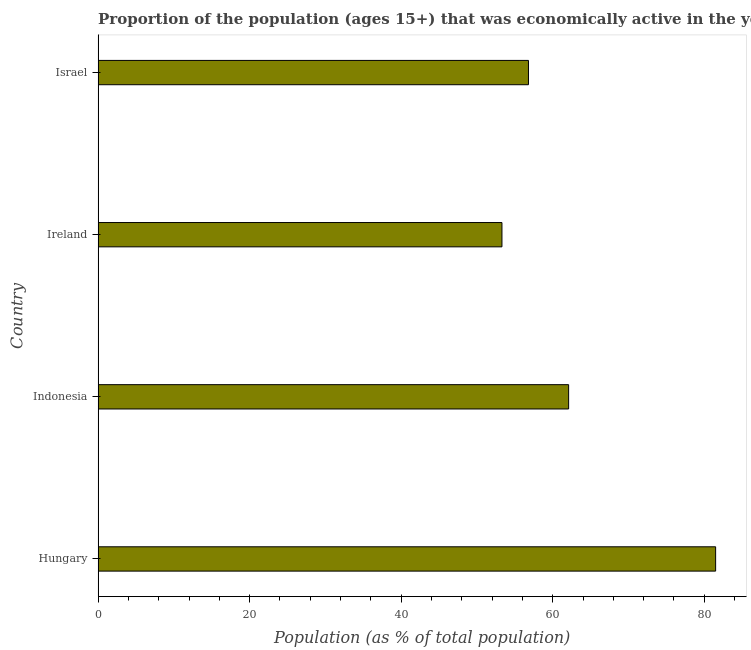Does the graph contain any zero values?
Offer a terse response. No. Does the graph contain grids?
Make the answer very short. No. What is the title of the graph?
Provide a short and direct response. Proportion of the population (ages 15+) that was economically active in the year 1985. What is the label or title of the X-axis?
Keep it short and to the point. Population (as % of total population). What is the percentage of economically active population in Indonesia?
Your answer should be very brief. 62.1. Across all countries, what is the maximum percentage of economically active population?
Make the answer very short. 81.5. Across all countries, what is the minimum percentage of economically active population?
Your answer should be compact. 53.3. In which country was the percentage of economically active population maximum?
Offer a terse response. Hungary. In which country was the percentage of economically active population minimum?
Offer a terse response. Ireland. What is the sum of the percentage of economically active population?
Ensure brevity in your answer.  253.7. What is the difference between the percentage of economically active population in Indonesia and Ireland?
Your response must be concise. 8.8. What is the average percentage of economically active population per country?
Offer a terse response. 63.42. What is the median percentage of economically active population?
Offer a very short reply. 59.45. In how many countries, is the percentage of economically active population greater than 72 %?
Your response must be concise. 1. What is the ratio of the percentage of economically active population in Hungary to that in Indonesia?
Provide a short and direct response. 1.31. Is the difference between the percentage of economically active population in Ireland and Israel greater than the difference between any two countries?
Offer a terse response. No. What is the difference between the highest and the second highest percentage of economically active population?
Your answer should be very brief. 19.4. What is the difference between the highest and the lowest percentage of economically active population?
Your answer should be compact. 28.2. In how many countries, is the percentage of economically active population greater than the average percentage of economically active population taken over all countries?
Ensure brevity in your answer.  1. How many bars are there?
Provide a short and direct response. 4. Are all the bars in the graph horizontal?
Your response must be concise. Yes. What is the difference between two consecutive major ticks on the X-axis?
Offer a terse response. 20. What is the Population (as % of total population) of Hungary?
Your answer should be very brief. 81.5. What is the Population (as % of total population) of Indonesia?
Offer a very short reply. 62.1. What is the Population (as % of total population) of Ireland?
Ensure brevity in your answer.  53.3. What is the Population (as % of total population) in Israel?
Ensure brevity in your answer.  56.8. What is the difference between the Population (as % of total population) in Hungary and Indonesia?
Your answer should be very brief. 19.4. What is the difference between the Population (as % of total population) in Hungary and Ireland?
Give a very brief answer. 28.2. What is the difference between the Population (as % of total population) in Hungary and Israel?
Your response must be concise. 24.7. What is the difference between the Population (as % of total population) in Indonesia and Ireland?
Offer a very short reply. 8.8. What is the difference between the Population (as % of total population) in Indonesia and Israel?
Offer a very short reply. 5.3. What is the difference between the Population (as % of total population) in Ireland and Israel?
Your response must be concise. -3.5. What is the ratio of the Population (as % of total population) in Hungary to that in Indonesia?
Offer a terse response. 1.31. What is the ratio of the Population (as % of total population) in Hungary to that in Ireland?
Offer a terse response. 1.53. What is the ratio of the Population (as % of total population) in Hungary to that in Israel?
Provide a succinct answer. 1.44. What is the ratio of the Population (as % of total population) in Indonesia to that in Ireland?
Your answer should be very brief. 1.17. What is the ratio of the Population (as % of total population) in Indonesia to that in Israel?
Provide a short and direct response. 1.09. What is the ratio of the Population (as % of total population) in Ireland to that in Israel?
Keep it short and to the point. 0.94. 